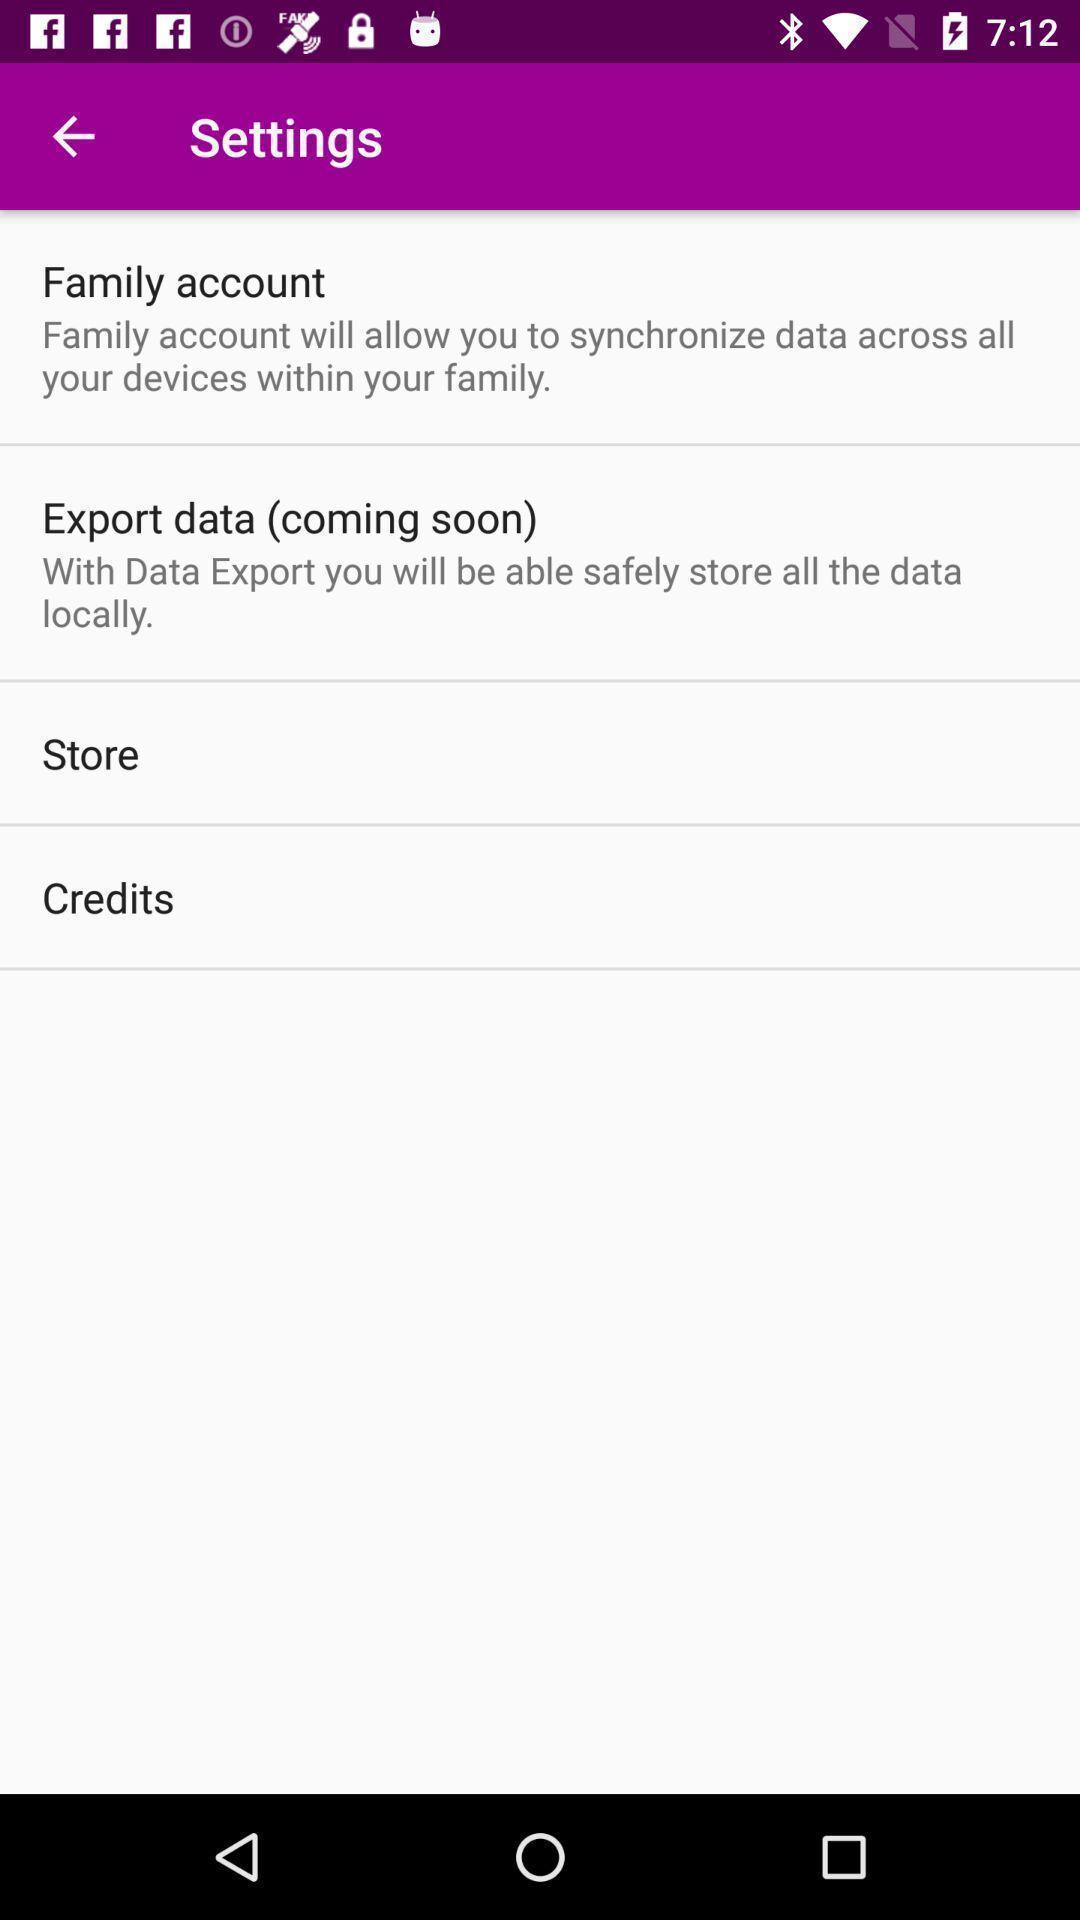Summarize the information in this screenshot. Settings page. 